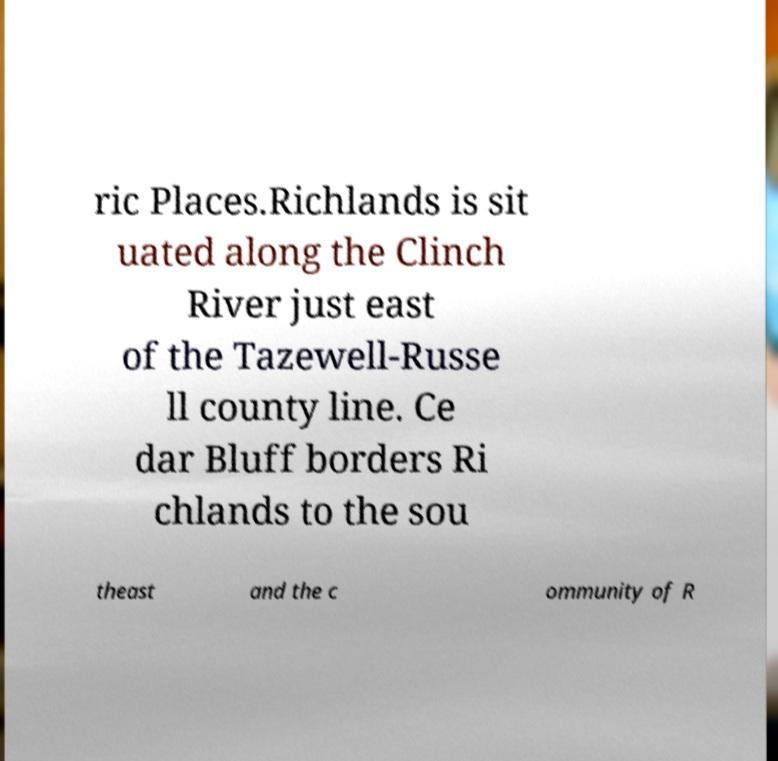Can you accurately transcribe the text from the provided image for me? ric Places.Richlands is sit uated along the Clinch River just east of the Tazewell-Russe ll county line. Ce dar Bluff borders Ri chlands to the sou theast and the c ommunity of R 